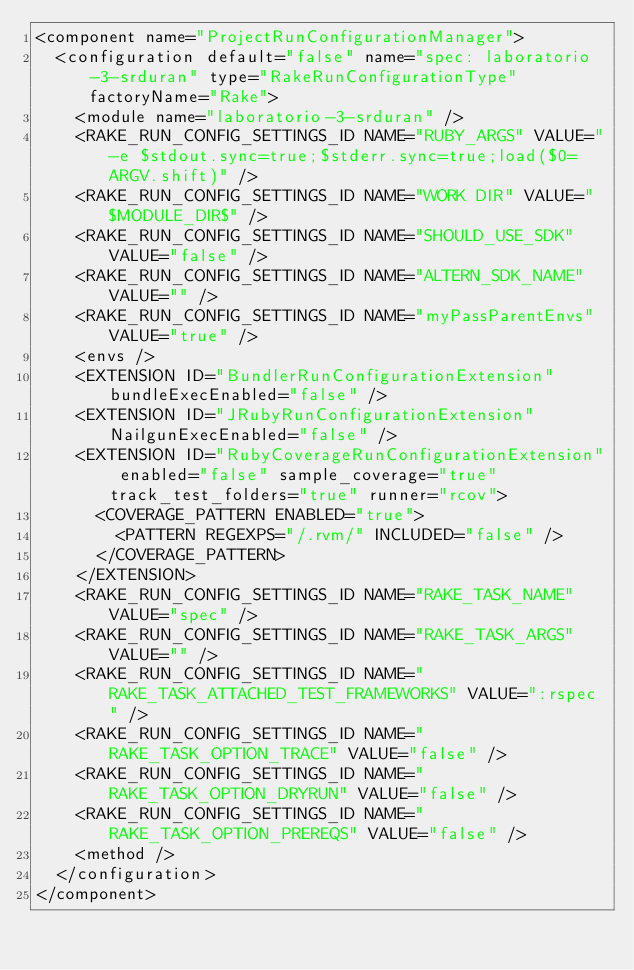Convert code to text. <code><loc_0><loc_0><loc_500><loc_500><_XML_><component name="ProjectRunConfigurationManager">
  <configuration default="false" name="spec: laboratorio-3-srduran" type="RakeRunConfigurationType" factoryName="Rake">
    <module name="laboratorio-3-srduran" />
    <RAKE_RUN_CONFIG_SETTINGS_ID NAME="RUBY_ARGS" VALUE="-e $stdout.sync=true;$stderr.sync=true;load($0=ARGV.shift)" />
    <RAKE_RUN_CONFIG_SETTINGS_ID NAME="WORK DIR" VALUE="$MODULE_DIR$" />
    <RAKE_RUN_CONFIG_SETTINGS_ID NAME="SHOULD_USE_SDK" VALUE="false" />
    <RAKE_RUN_CONFIG_SETTINGS_ID NAME="ALTERN_SDK_NAME" VALUE="" />
    <RAKE_RUN_CONFIG_SETTINGS_ID NAME="myPassParentEnvs" VALUE="true" />
    <envs />
    <EXTENSION ID="BundlerRunConfigurationExtension" bundleExecEnabled="false" />
    <EXTENSION ID="JRubyRunConfigurationExtension" NailgunExecEnabled="false" />
    <EXTENSION ID="RubyCoverageRunConfigurationExtension" enabled="false" sample_coverage="true" track_test_folders="true" runner="rcov">
      <COVERAGE_PATTERN ENABLED="true">
        <PATTERN REGEXPS="/.rvm/" INCLUDED="false" />
      </COVERAGE_PATTERN>
    </EXTENSION>
    <RAKE_RUN_CONFIG_SETTINGS_ID NAME="RAKE_TASK_NAME" VALUE="spec" />
    <RAKE_RUN_CONFIG_SETTINGS_ID NAME="RAKE_TASK_ARGS" VALUE="" />
    <RAKE_RUN_CONFIG_SETTINGS_ID NAME="RAKE_TASK_ATTACHED_TEST_FRAMEWORKS" VALUE=":rspec " />
    <RAKE_RUN_CONFIG_SETTINGS_ID NAME="RAKE_TASK_OPTION_TRACE" VALUE="false" />
    <RAKE_RUN_CONFIG_SETTINGS_ID NAME="RAKE_TASK_OPTION_DRYRUN" VALUE="false" />
    <RAKE_RUN_CONFIG_SETTINGS_ID NAME="RAKE_TASK_OPTION_PREREQS" VALUE="false" />
    <method />
  </configuration>
</component></code> 